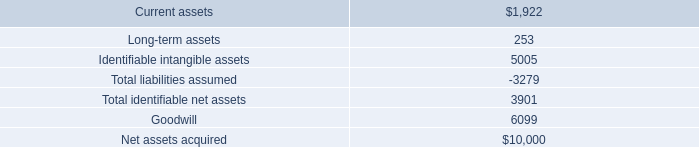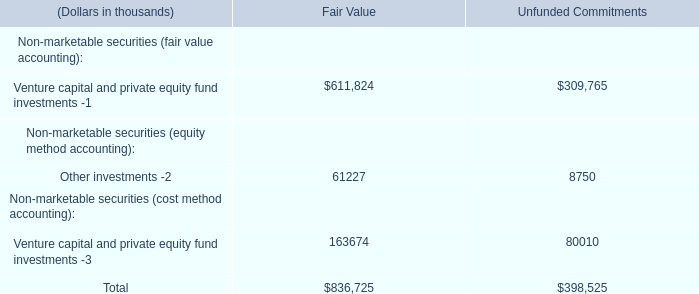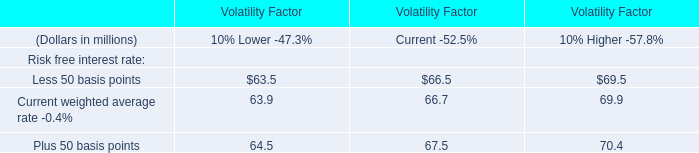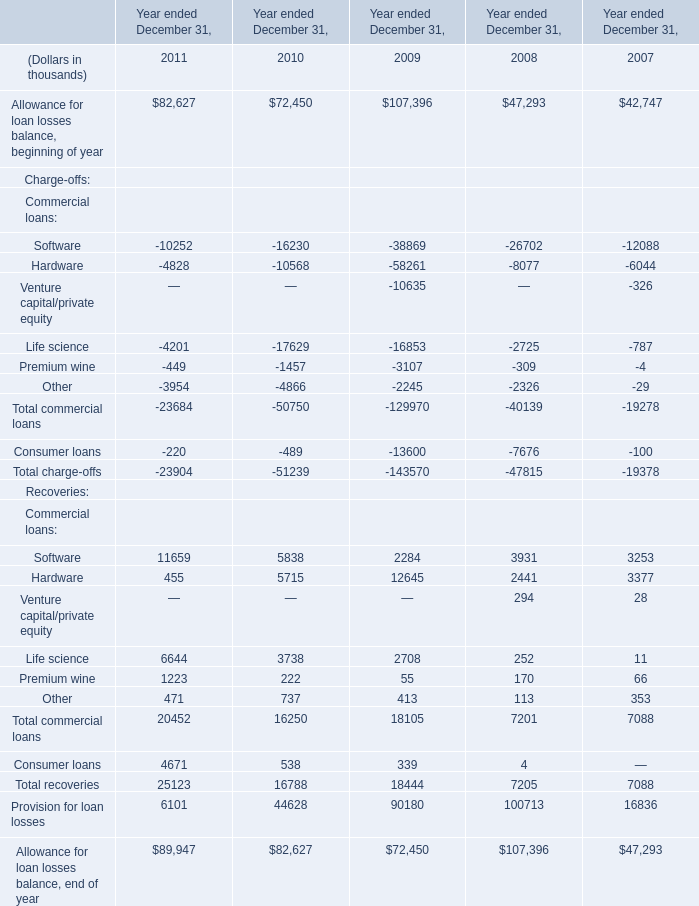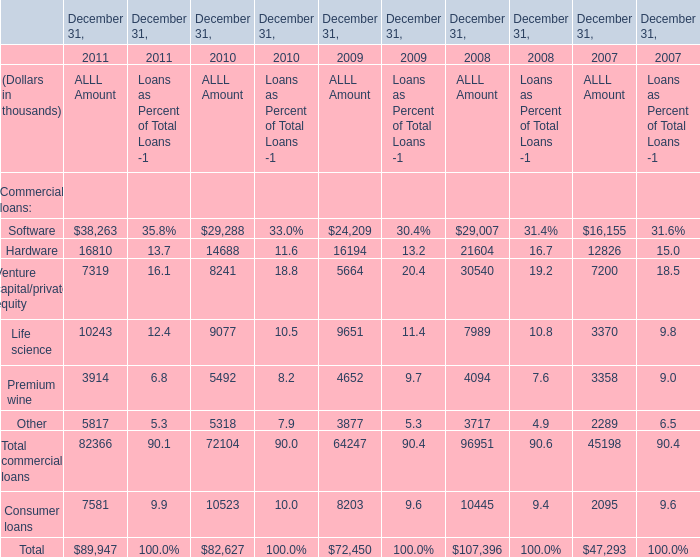What was the total amount of elements for greater than 10000 in 2011? (in thousand) 
Computations: ((38263 + 16810) + 10243)
Answer: 65316.0. 